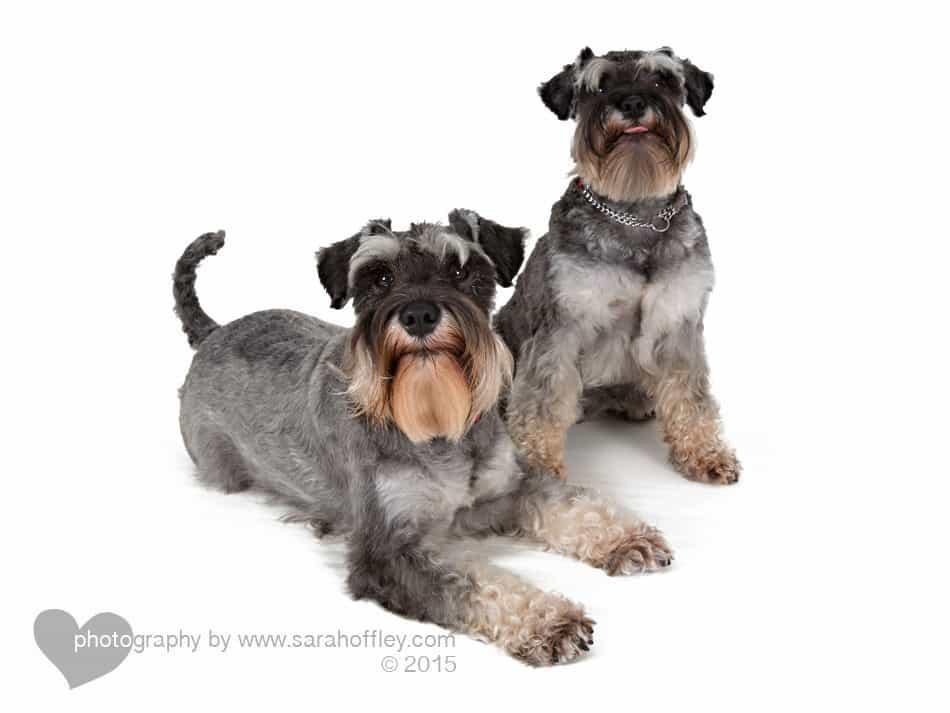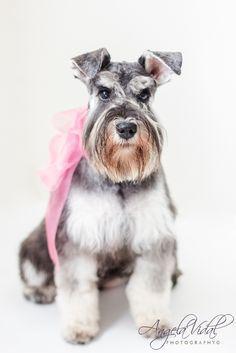The first image is the image on the left, the second image is the image on the right. For the images displayed, is the sentence "There are at least 3 dogs and 2 are sitting in these." factually correct? Answer yes or no. Yes. The first image is the image on the left, the second image is the image on the right. Evaluate the accuracy of this statement regarding the images: "in the right pic the dog is wearing something". Is it true? Answer yes or no. Yes. 